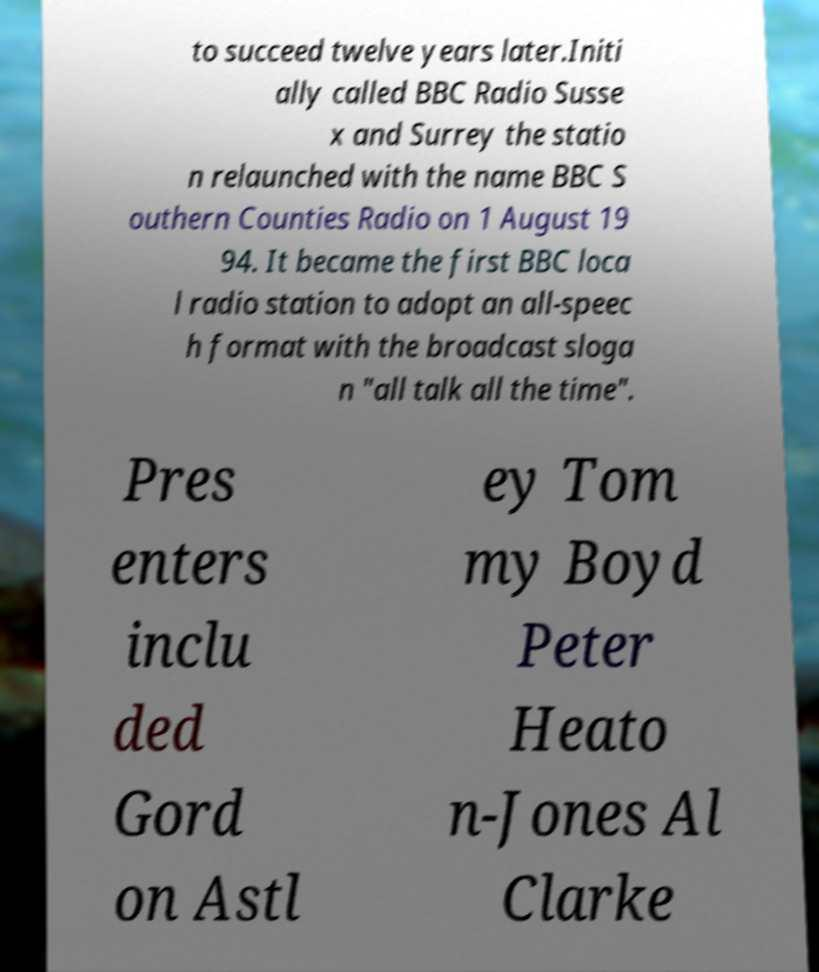I need the written content from this picture converted into text. Can you do that? to succeed twelve years later.Initi ally called BBC Radio Susse x and Surrey the statio n relaunched with the name BBC S outhern Counties Radio on 1 August 19 94. It became the first BBC loca l radio station to adopt an all-speec h format with the broadcast sloga n "all talk all the time". Pres enters inclu ded Gord on Astl ey Tom my Boyd Peter Heato n-Jones Al Clarke 